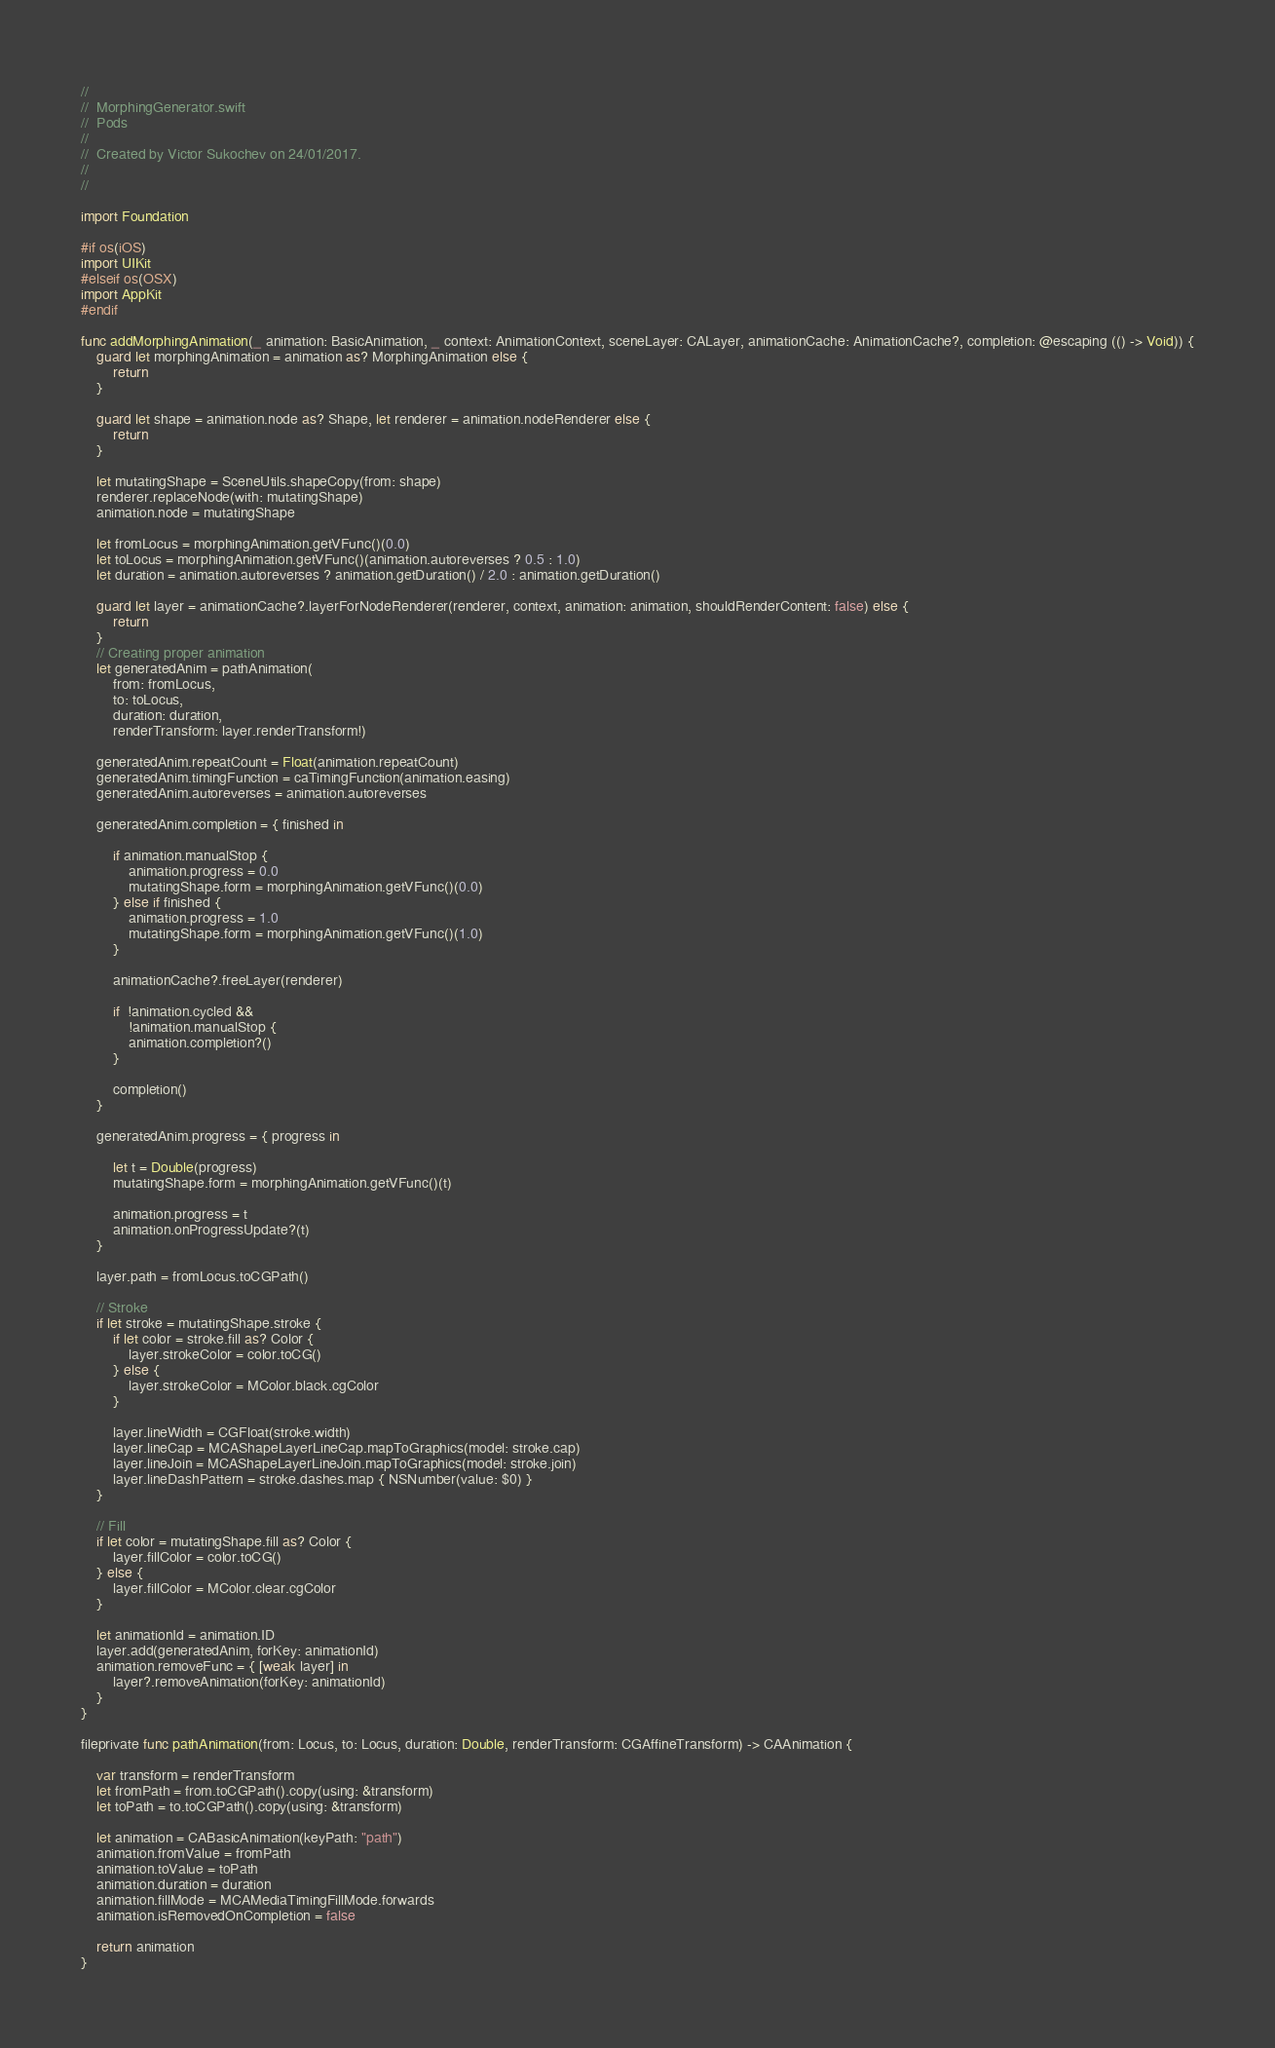Convert code to text. <code><loc_0><loc_0><loc_500><loc_500><_Swift_>//
//  MorphingGenerator.swift
//  Pods
//
//  Created by Victor Sukochev on 24/01/2017.
//
//

import Foundation

#if os(iOS)
import UIKit
#elseif os(OSX)
import AppKit
#endif

func addMorphingAnimation(_ animation: BasicAnimation, _ context: AnimationContext, sceneLayer: CALayer, animationCache: AnimationCache?, completion: @escaping (() -> Void)) {
    guard let morphingAnimation = animation as? MorphingAnimation else {
        return
    }

    guard let shape = animation.node as? Shape, let renderer = animation.nodeRenderer else {
        return
    }

    let mutatingShape = SceneUtils.shapeCopy(from: shape)
    renderer.replaceNode(with: mutatingShape)
    animation.node = mutatingShape

    let fromLocus = morphingAnimation.getVFunc()(0.0)
    let toLocus = morphingAnimation.getVFunc()(animation.autoreverses ? 0.5 : 1.0)
    let duration = animation.autoreverses ? animation.getDuration() / 2.0 : animation.getDuration()

    guard let layer = animationCache?.layerForNodeRenderer(renderer, context, animation: animation, shouldRenderContent: false) else {
        return
    }
    // Creating proper animation
    let generatedAnim = pathAnimation(
        from: fromLocus,
        to: toLocus,
        duration: duration,
        renderTransform: layer.renderTransform!)

    generatedAnim.repeatCount = Float(animation.repeatCount)
    generatedAnim.timingFunction = caTimingFunction(animation.easing)
    generatedAnim.autoreverses = animation.autoreverses

    generatedAnim.completion = { finished in

        if animation.manualStop {
            animation.progress = 0.0
            mutatingShape.form = morphingAnimation.getVFunc()(0.0)
        } else if finished {
            animation.progress = 1.0
            mutatingShape.form = morphingAnimation.getVFunc()(1.0)
        }

        animationCache?.freeLayer(renderer)

        if  !animation.cycled &&
            !animation.manualStop {
            animation.completion?()
        }

        completion()
    }

    generatedAnim.progress = { progress in

        let t = Double(progress)
        mutatingShape.form = morphingAnimation.getVFunc()(t)

        animation.progress = t
        animation.onProgressUpdate?(t)
    }

    layer.path = fromLocus.toCGPath()

    // Stroke
    if let stroke = mutatingShape.stroke {
        if let color = stroke.fill as? Color {
            layer.strokeColor = color.toCG()
        } else {
            layer.strokeColor = MColor.black.cgColor
        }

        layer.lineWidth = CGFloat(stroke.width)
        layer.lineCap = MCAShapeLayerLineCap.mapToGraphics(model: stroke.cap)
        layer.lineJoin = MCAShapeLayerLineJoin.mapToGraphics(model: stroke.join)
        layer.lineDashPattern = stroke.dashes.map { NSNumber(value: $0) }
    }

    // Fill
    if let color = mutatingShape.fill as? Color {
        layer.fillColor = color.toCG()
    } else {
        layer.fillColor = MColor.clear.cgColor
    }

    let animationId = animation.ID
    layer.add(generatedAnim, forKey: animationId)
    animation.removeFunc = { [weak layer] in
        layer?.removeAnimation(forKey: animationId)
    }
}

fileprivate func pathAnimation(from: Locus, to: Locus, duration: Double, renderTransform: CGAffineTransform) -> CAAnimation {

    var transform = renderTransform
    let fromPath = from.toCGPath().copy(using: &transform)
    let toPath = to.toCGPath().copy(using: &transform)

    let animation = CABasicAnimation(keyPath: "path")
    animation.fromValue = fromPath
    animation.toValue = toPath
    animation.duration = duration
    animation.fillMode = MCAMediaTimingFillMode.forwards
    animation.isRemovedOnCompletion = false

    return animation
}
</code> 